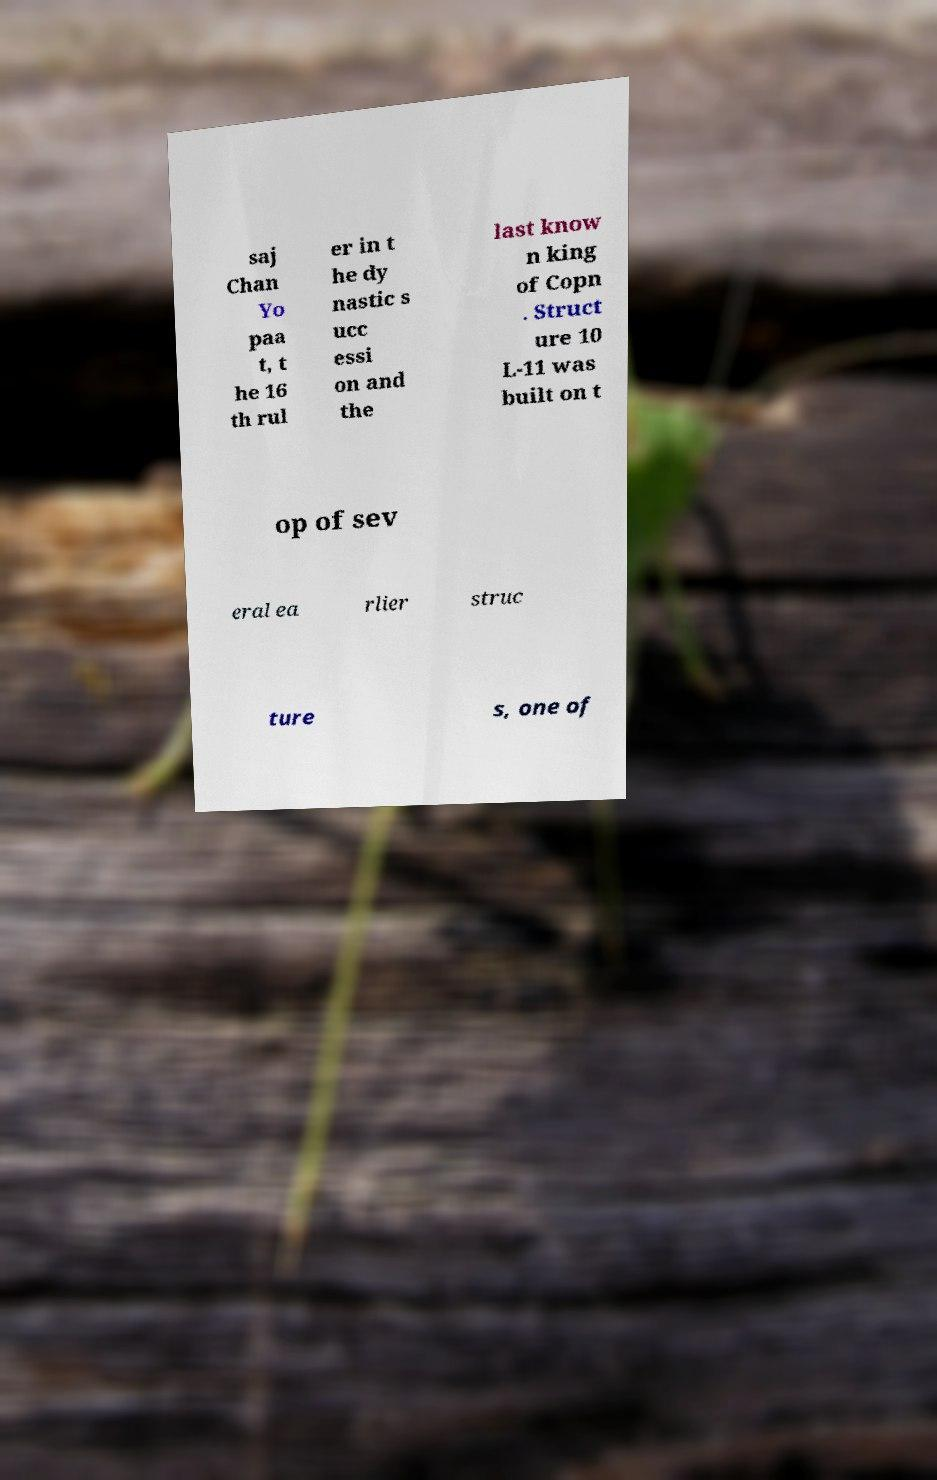What messages or text are displayed in this image? I need them in a readable, typed format. saj Chan Yo paa t, t he 16 th rul er in t he dy nastic s ucc essi on and the last know n king of Copn . Struct ure 10 L-11 was built on t op of sev eral ea rlier struc ture s, one of 